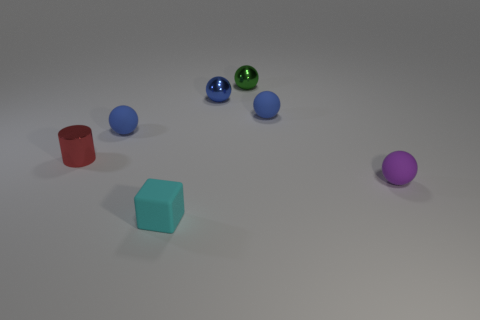Is the color of the matte ball that is left of the cyan rubber cube the same as the tiny shiny ball that is left of the green shiny thing?
Make the answer very short. Yes. What is the ball in front of the tiny cylinder made of?
Your answer should be very brief. Rubber. What is the color of the tiny cylinder that is the same material as the tiny green sphere?
Keep it short and to the point. Red. How many other objects are the same size as the purple object?
Your response must be concise. 6. What is the shape of the tiny shiny object that is in front of the green thing and right of the tiny red cylinder?
Your answer should be compact. Sphere. Are there any rubber spheres to the left of the tiny blue shiny sphere?
Your response must be concise. Yes. Is there anything else that is the same shape as the small green object?
Provide a succinct answer. Yes. Does the purple rubber thing have the same shape as the small green metal thing?
Offer a terse response. Yes. Is the number of tiny blue rubber balls that are to the left of the small cyan thing the same as the number of small purple spheres on the left side of the small blue metallic thing?
Offer a terse response. No. How many other objects are the same material as the small cylinder?
Provide a succinct answer. 2. 